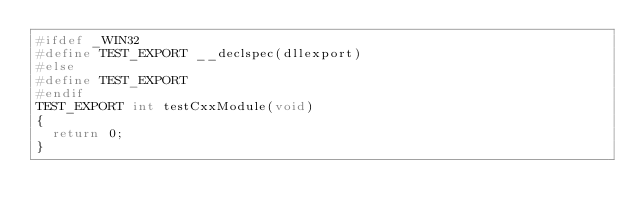Convert code to text. <code><loc_0><loc_0><loc_500><loc_500><_C++_>#ifdef _WIN32
#define TEST_EXPORT __declspec(dllexport)
#else
#define TEST_EXPORT
#endif
TEST_EXPORT int testCxxModule(void)
{
  return 0;
}
</code> 